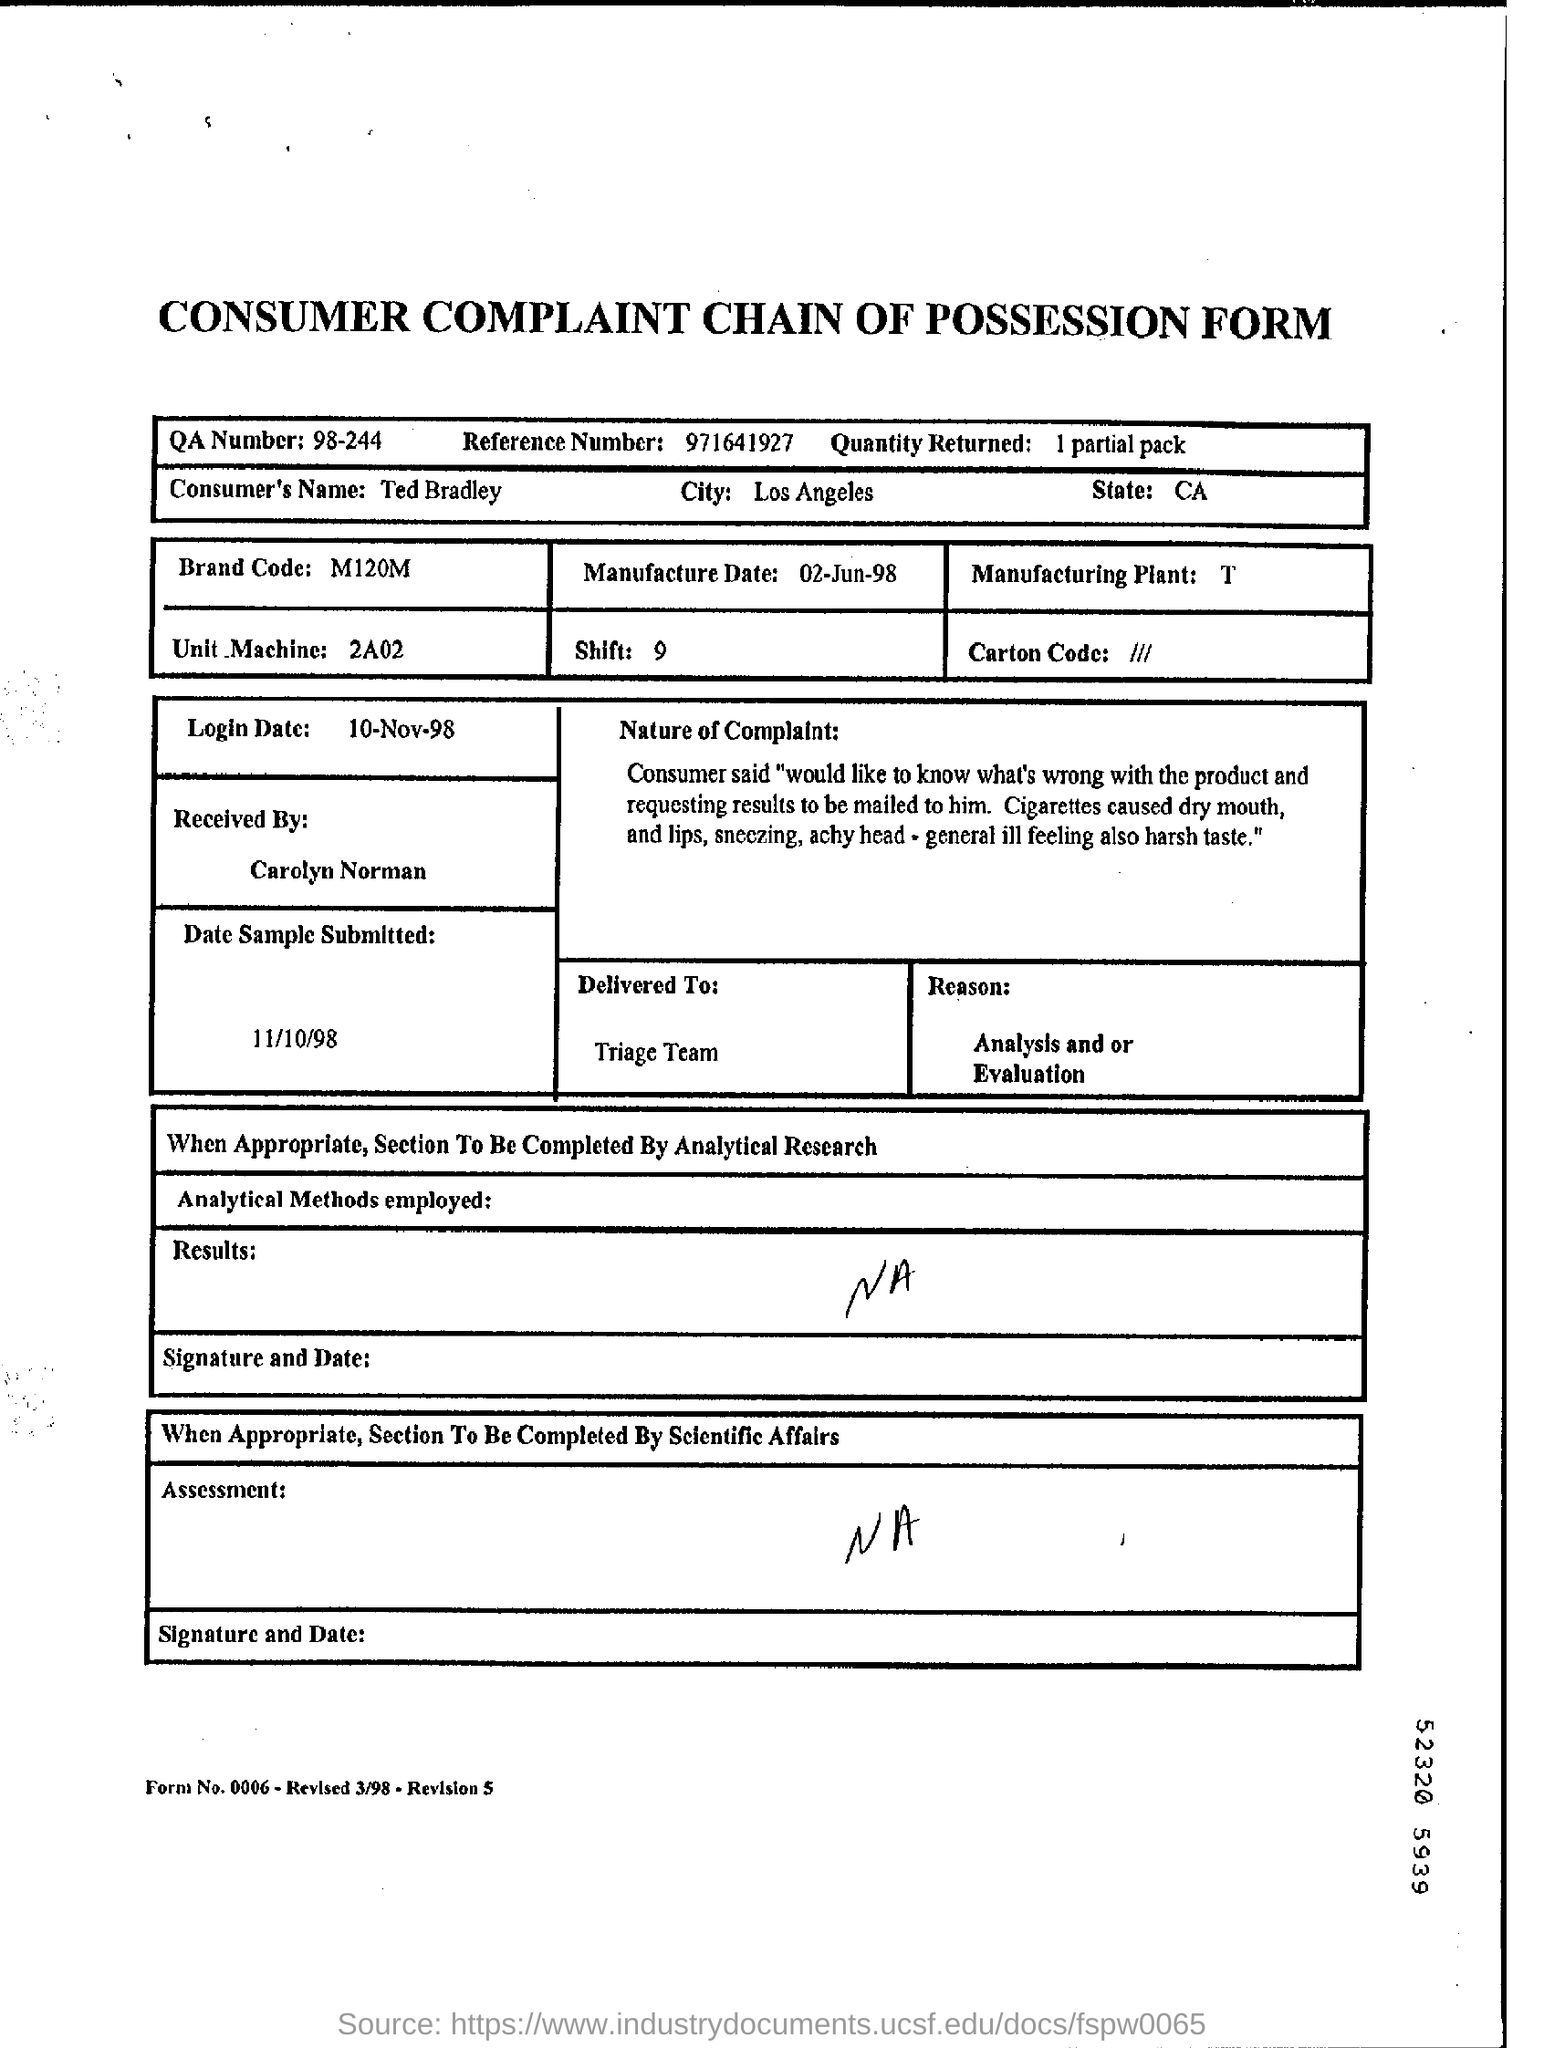What is the QA number?
Provide a short and direct response. 98-244. What is the reference number given?
Your response must be concise. 971641927. What was the brand code?
Ensure brevity in your answer.  M120M. Who received the complaint?
Your response must be concise. Carolyn Norman. What is the reason given?
Keep it short and to the point. Analysis and or Evaluation. 